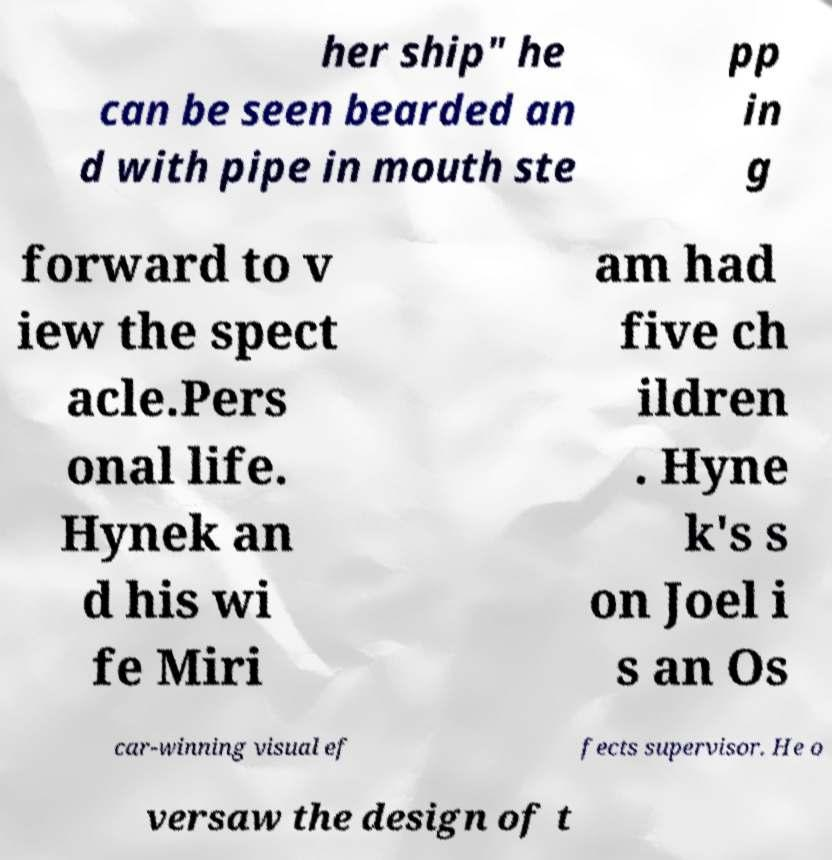Please read and relay the text visible in this image. What does it say? her ship" he can be seen bearded an d with pipe in mouth ste pp in g forward to v iew the spect acle.Pers onal life. Hynek an d his wi fe Miri am had five ch ildren . Hyne k's s on Joel i s an Os car-winning visual ef fects supervisor. He o versaw the design of t 